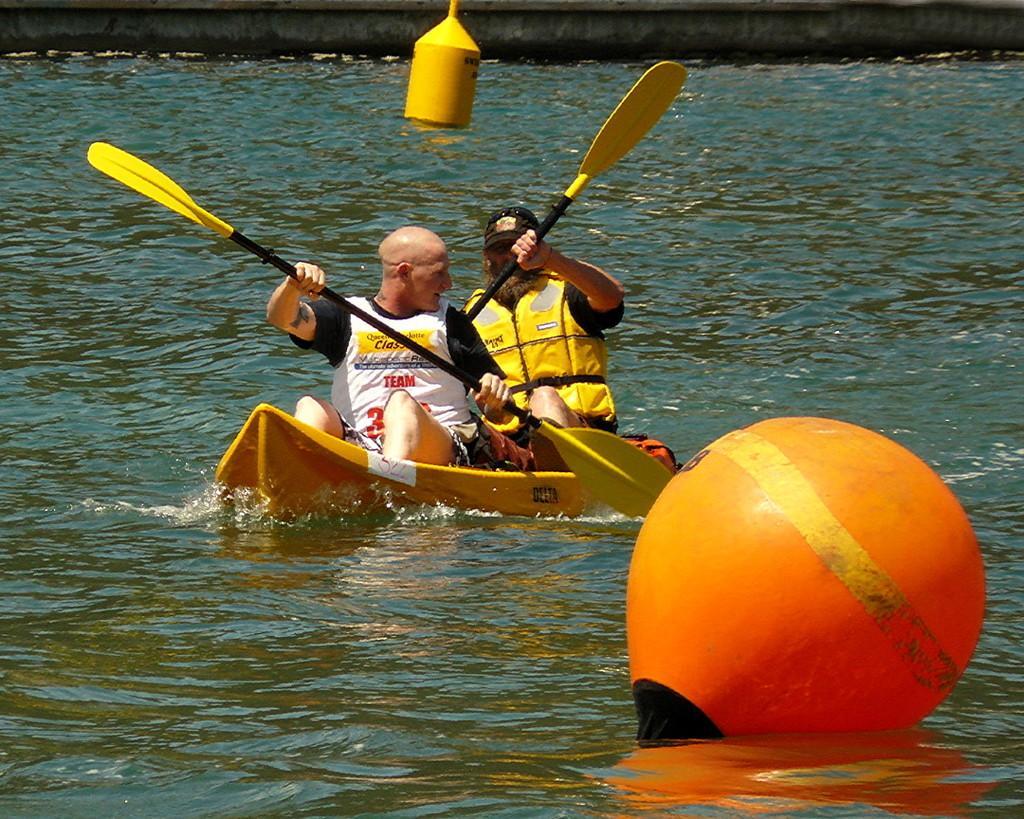Please provide a concise description of this image. In this image we can see a lake. There are two persons rowing a boat. There are few floating objects on the water. 